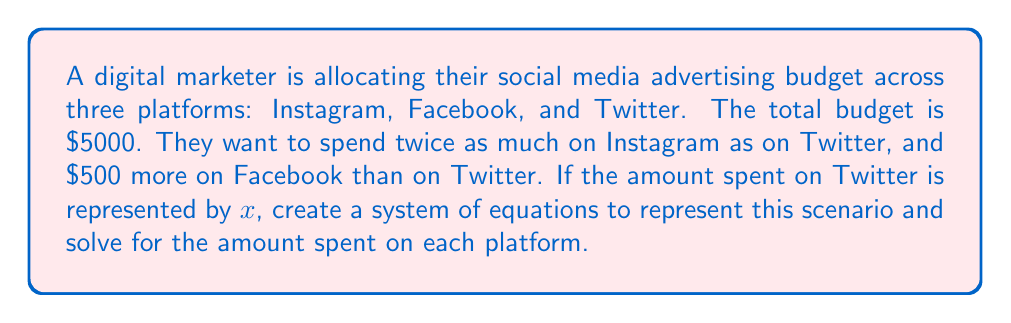Could you help me with this problem? Let's approach this step-by-step:

1) Define variables:
   Let $x$ = amount spent on Twitter
   Let $y$ = amount spent on Instagram
   Let $z$ = amount spent on Facebook

2) Create equations based on the given information:
   - Total budget: $x + y + z = 5000$
   - Instagram is twice Twitter: $y = 2x$
   - Facebook is $500 more than Twitter: $z = x + 500$

3) Substitute the expressions for $y$ and $z$ into the total budget equation:
   $x + 2x + (x + 500) = 5000$

4) Simplify the equation:
   $4x + 500 = 5000$

5) Solve for $x$:
   $4x = 4500$
   $x = 1125$

6) Now that we know $x$, we can find $y$ and $z$:
   $y = 2x = 2(1125) = 2250$
   $z = x + 500 = 1125 + 500 = 1625$

7) Verify the solution:
   $x + y + z = 1125 + 2250 + 1625 = 5000$

Therefore, the budget allocation is:
Twitter: $1125
Instagram: $2250
Facebook: $1625
Answer: Twitter: $1125, Instagram: $2250, Facebook: $1625 